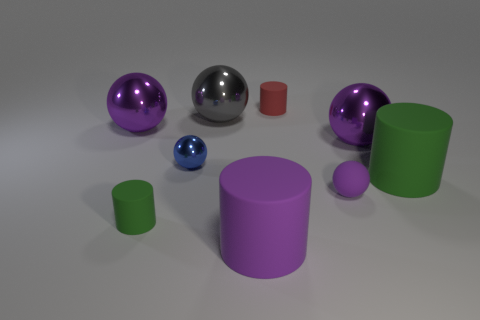Subtract all big green rubber cylinders. How many cylinders are left? 3 Subtract all red cylinders. How many cylinders are left? 3 Subtract 1 spheres. How many spheres are left? 4 Add 6 metal objects. How many metal objects exist? 10 Subtract 0 red balls. How many objects are left? 9 Subtract all balls. How many objects are left? 4 Subtract all blue balls. Subtract all green cylinders. How many balls are left? 4 Subtract all yellow cubes. How many yellow cylinders are left? 0 Subtract all tiny spheres. Subtract all yellow matte things. How many objects are left? 7 Add 7 green matte objects. How many green matte objects are left? 9 